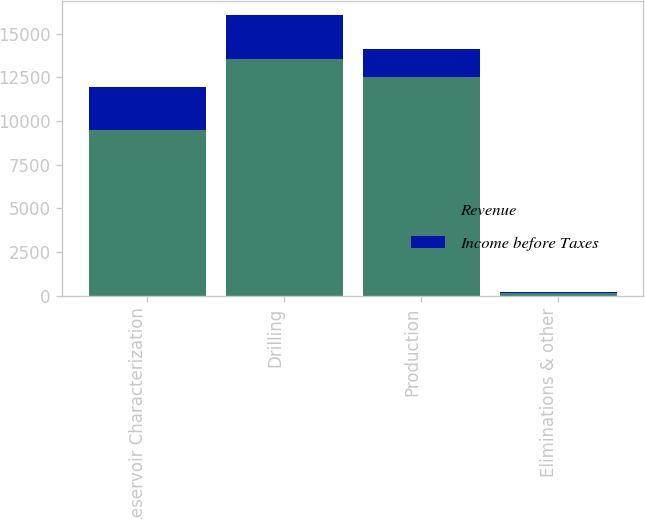Convert chart. <chart><loc_0><loc_0><loc_500><loc_500><stacked_bar_chart><ecel><fcel>Reservoir Characterization<fcel>Drilling<fcel>Production<fcel>Eliminations & other<nl><fcel>Revenue<fcel>9501<fcel>13563<fcel>12548<fcel>137<nl><fcel>Income before Taxes<fcel>2450<fcel>2538<fcel>1585<fcel>63<nl></chart> 